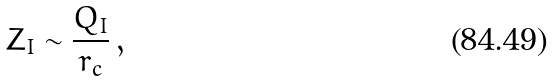<formula> <loc_0><loc_0><loc_500><loc_500>Z _ { I } \sim \frac { Q _ { I } } { r _ { c } } \, ,</formula> 